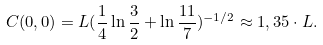<formula> <loc_0><loc_0><loc_500><loc_500>C ( 0 , 0 ) = L ( \frac { 1 } { 4 } \ln { \frac { 3 } { 2 } } + \ln { \frac { 1 1 } { 7 } } ) ^ { - 1 / 2 } \approx 1 , 3 5 \cdot L .</formula> 